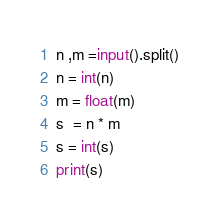<code> <loc_0><loc_0><loc_500><loc_500><_Python_>n ,m =input().split()
n = int(n)
m = float(m)
s  = n * m
s = int(s)
print(s)</code> 